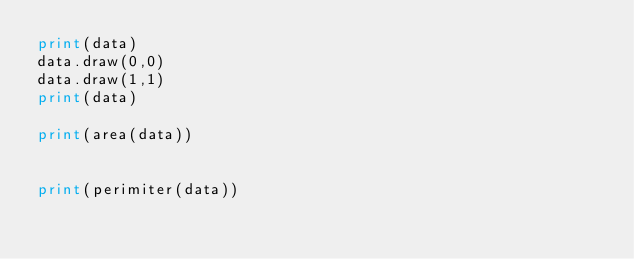Convert code to text. <code><loc_0><loc_0><loc_500><loc_500><_Python_>print(data)
data.draw(0,0)
data.draw(1,1)
print(data)

print(area(data))


print(perimiter(data))</code> 